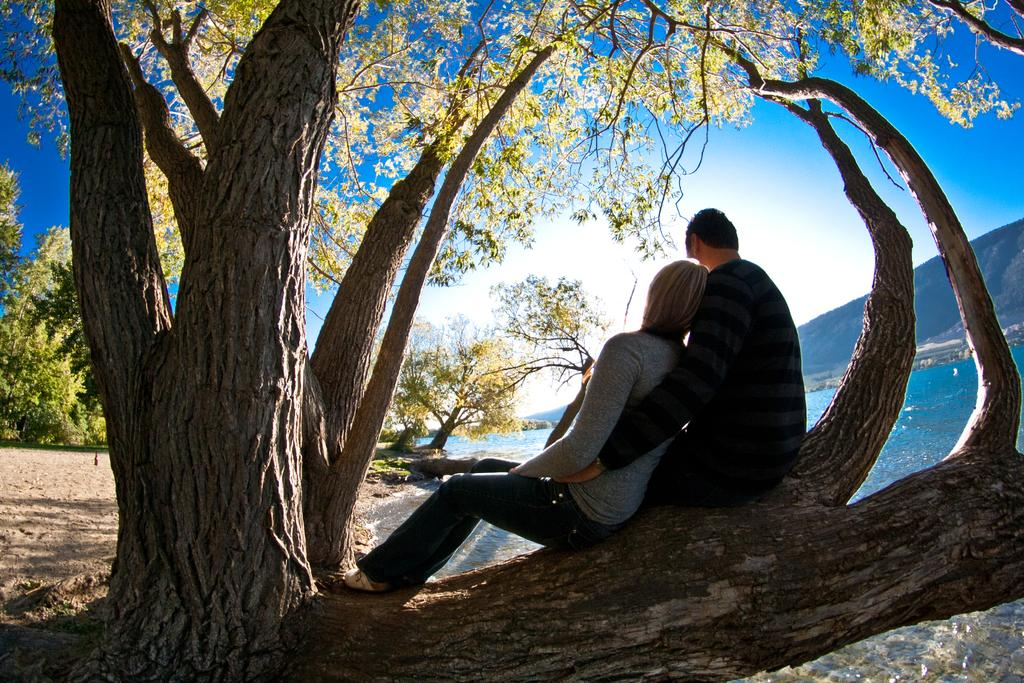How many people are sitting on the tree branch in the image? There are 2 people sitting on a tree branch in the image. What can be seen behind the people sitting on the tree branch? There are trees at the back in the image. What is visible on the right side of the image? There is water and mountains visible on the right side of the image. What is visible at the top of the image? The sky is visible at the top of the image. What flavor of kettle is being used to cook the people sitting on the tree branch in the image? There is no kettle or cooking activity present in the image; it features two people sitting on a tree branch. 